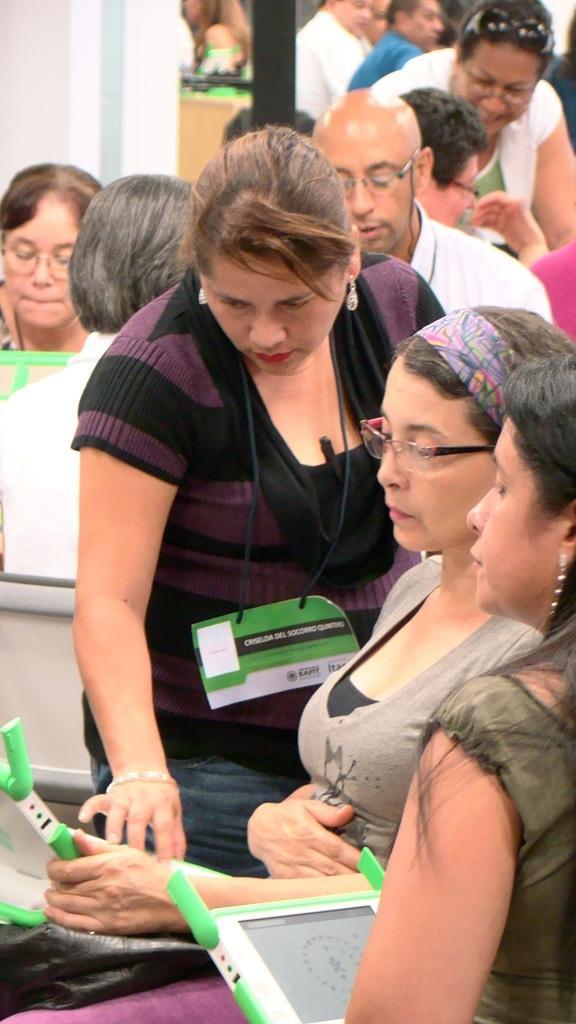In one or two sentences, can you explain what this image depicts? In this image there are people some of holding tablets. In the background there is a wall. 